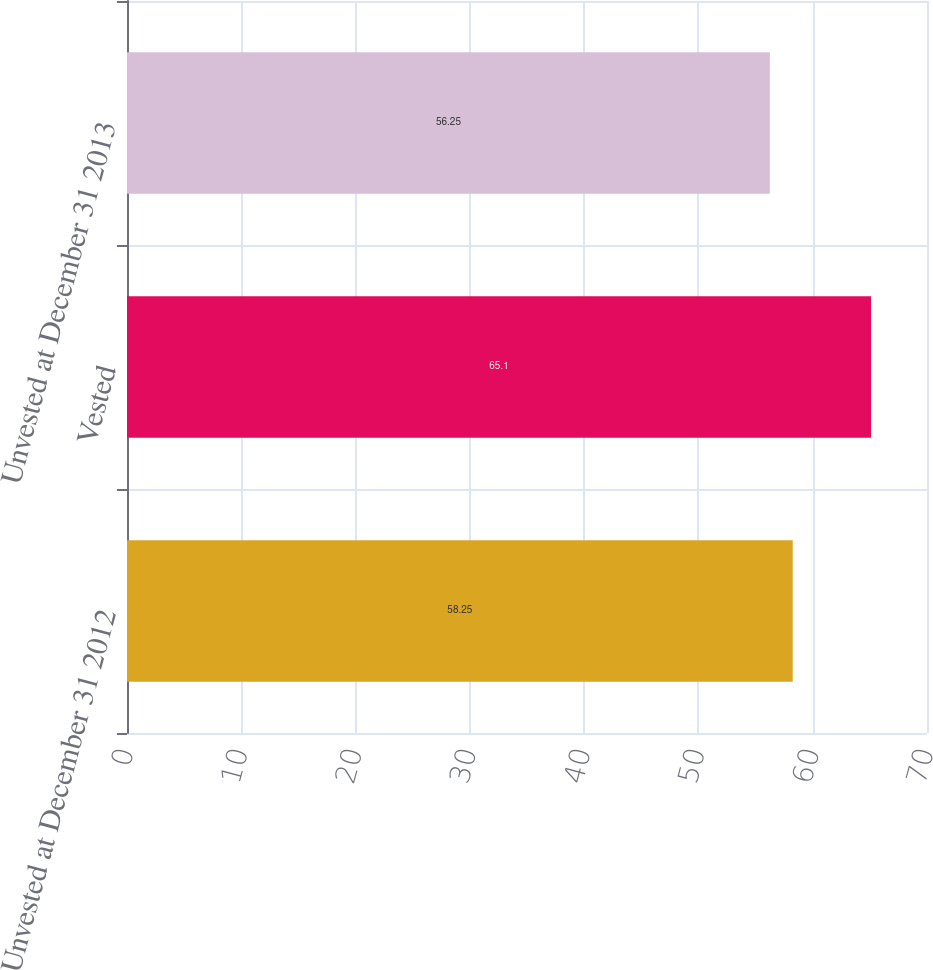Convert chart to OTSL. <chart><loc_0><loc_0><loc_500><loc_500><bar_chart><fcel>Unvested at December 31 2012<fcel>Vested<fcel>Unvested at December 31 2013<nl><fcel>58.25<fcel>65.1<fcel>56.25<nl></chart> 